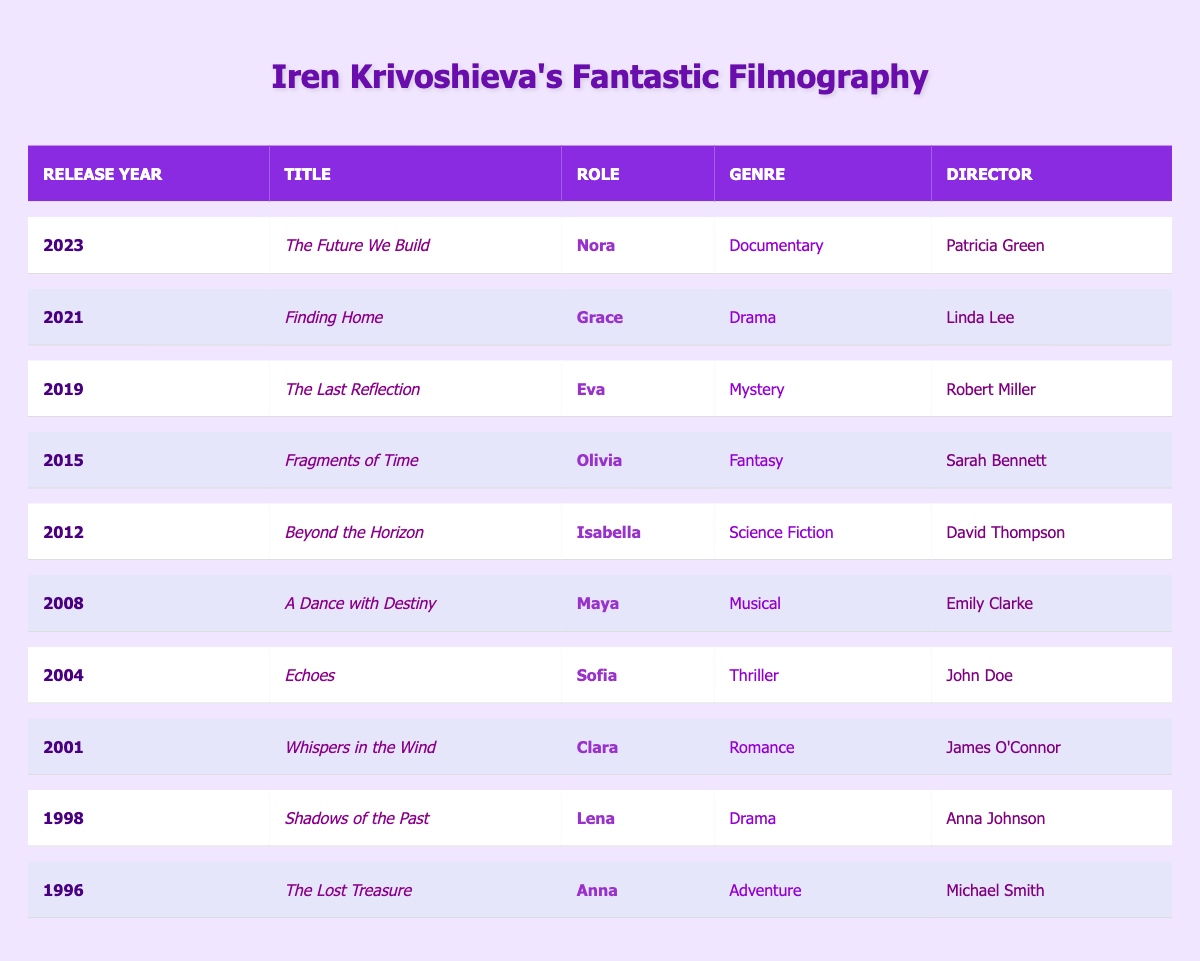What is the title of Iren Krivoshieva's film released in 2023? The table lists several films along with their release years. I can locate the row where the Release Year is 2023, which shows the title "The Future We Build."
Answer: The Future We Build Which role does Iren Krivoshieva play in the movie "Echoes"? By checking the row corresponding to the title "Echoes" in the table, the Role column indicates that she plays "Sofia."
Answer: Sofia How many films did Iren Krivoshieva star in during the 2000s? I need to count the films listed in the years from 2000 to 2009 in the table. The eligible films are five: "Whispers in the Wind" (2001), "Echoes" (2004), "A Dance with Destiny" (2008). So the total is three films.
Answer: Three What genre is the film "Fragments of Time"? The table provides film genres for each title. For "Fragments of Time," the Genre column indicates it is a Fantasy film.
Answer: Fantasy Is "Finding Home" a documentary? I can examine the Genre of "Finding Home" from the table. The Genre column states it's Drama, hence it is not a documentary.
Answer: No Which film has the director named "David Thompson"? I refer to the table and look for the director name, "David Thompson," that points me to the associated title "Beyond the Horizon."
Answer: Beyond the Horizon How many total genres are represented in Iren Krivoshieva's filmography? I analyze the Genre column for distinct classifications. The unique genres identified are Adventure, Drama, Romance, Thriller, Musical, Science Fiction, Fantasy, Mystery, and Documentary, totaling nine different genres.
Answer: Nine What are the roles played by Iren Krivoshieva in films released in 2019 and later? I check the table for the Release Years 2019, 2021, and 2023. The roles in these films are: Eva in "The Last Reflection" (2019), Grace in "Finding Home" (2021), and Nora in "The Future We Build" (2023).
Answer: Eva, Grace, Nora Which film marked Iren Krivoshieva's first appearance in her filmography? By examining the Release Year, the earliest year provided in the table is 1996, and that corresponds to the title "The Lost Treasure."
Answer: The Lost Treasure Which genre has the maximum number of films featuring Iren Krivoshieva? I review the table for genres and tally the number of films associated with each. The genres are as follows: Adventure (1), Drama (2), Romance (1), Thriller (1), Musical (1), Science Fiction (1), Fantasy (1), Mystery (1), Documentary (1). Drama has the highest count with two films.
Answer: Drama 